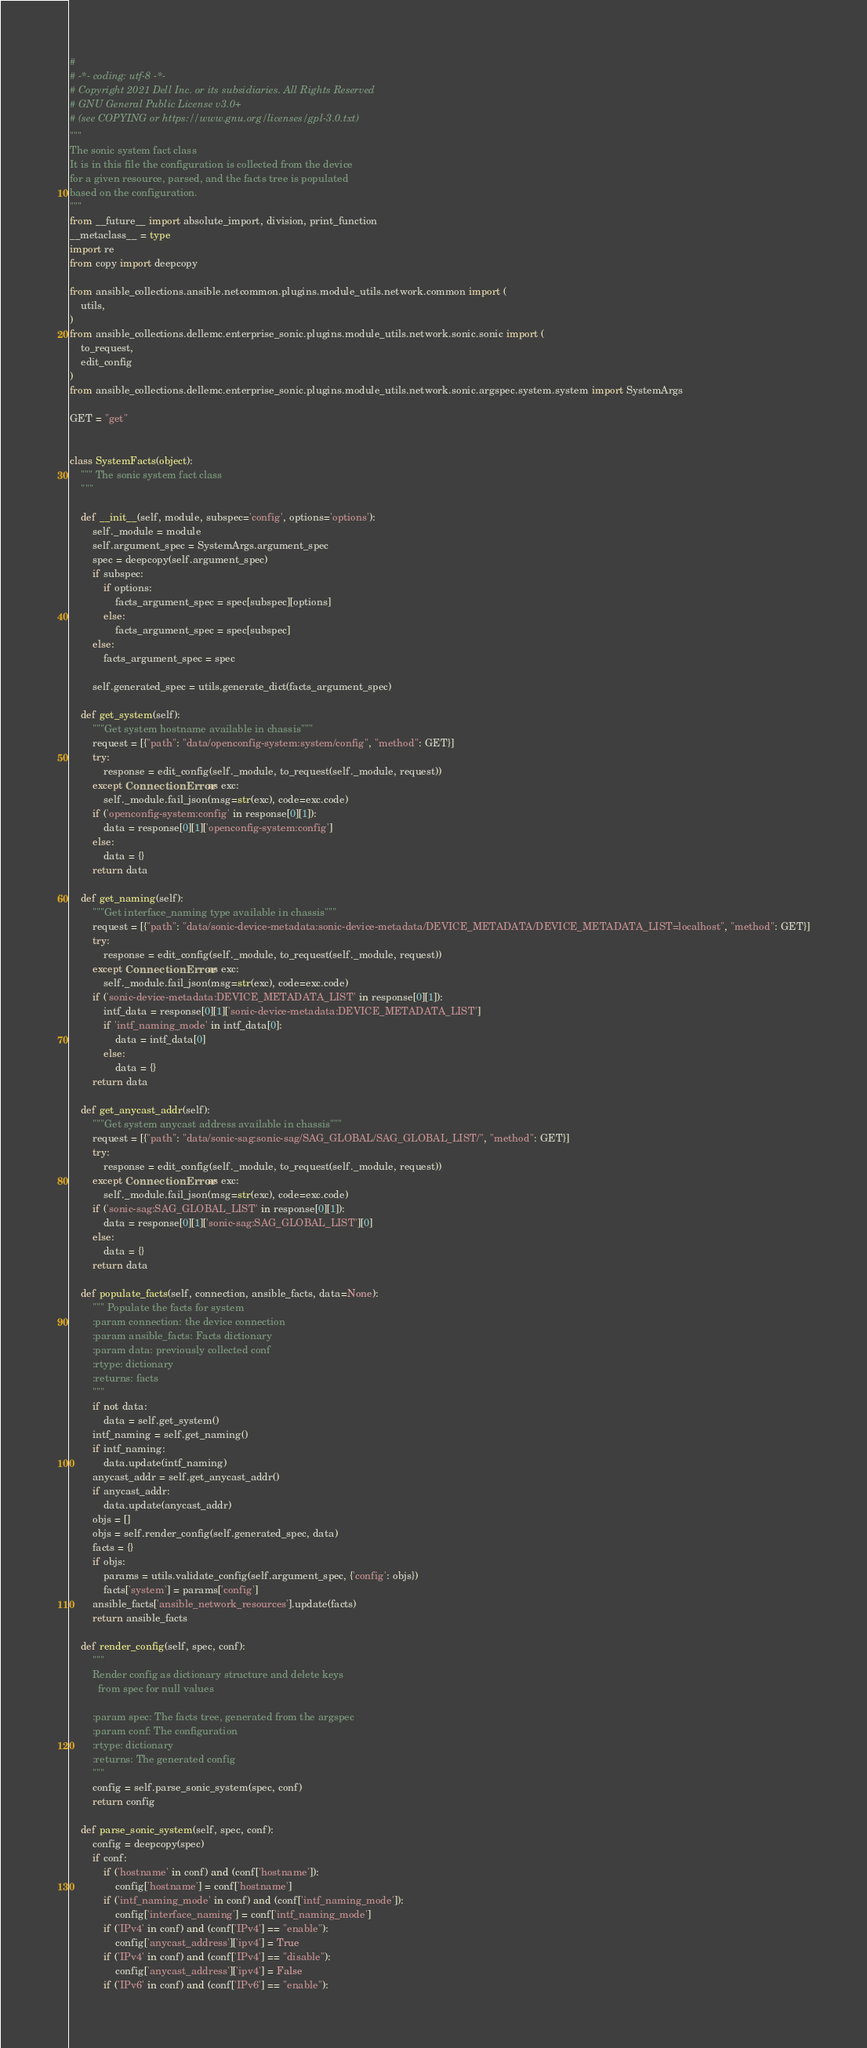Convert code to text. <code><loc_0><loc_0><loc_500><loc_500><_Python_>#
# -*- coding: utf-8 -*-
# Copyright 2021 Dell Inc. or its subsidiaries. All Rights Reserved
# GNU General Public License v3.0+
# (see COPYING or https://www.gnu.org/licenses/gpl-3.0.txt)
"""
The sonic system fact class
It is in this file the configuration is collected from the device
for a given resource, parsed, and the facts tree is populated
based on the configuration.
"""
from __future__ import absolute_import, division, print_function
__metaclass__ = type
import re
from copy import deepcopy

from ansible_collections.ansible.netcommon.plugins.module_utils.network.common import (
    utils,
)
from ansible_collections.dellemc.enterprise_sonic.plugins.module_utils.network.sonic.sonic import (
    to_request,
    edit_config
)
from ansible_collections.dellemc.enterprise_sonic.plugins.module_utils.network.sonic.argspec.system.system import SystemArgs

GET = "get"


class SystemFacts(object):
    """ The sonic system fact class
    """

    def __init__(self, module, subspec='config', options='options'):
        self._module = module
        self.argument_spec = SystemArgs.argument_spec
        spec = deepcopy(self.argument_spec)
        if subspec:
            if options:
                facts_argument_spec = spec[subspec][options]
            else:
                facts_argument_spec = spec[subspec]
        else:
            facts_argument_spec = spec

        self.generated_spec = utils.generate_dict(facts_argument_spec)

    def get_system(self):
        """Get system hostname available in chassis"""
        request = [{"path": "data/openconfig-system:system/config", "method": GET}]
        try:
            response = edit_config(self._module, to_request(self._module, request))
        except ConnectionError as exc:
            self._module.fail_json(msg=str(exc), code=exc.code)
        if ('openconfig-system:config' in response[0][1]):
            data = response[0][1]['openconfig-system:config']
        else:
            data = {}
        return data

    def get_naming(self):
        """Get interface_naming type available in chassis"""
        request = [{"path": "data/sonic-device-metadata:sonic-device-metadata/DEVICE_METADATA/DEVICE_METADATA_LIST=localhost", "method": GET}]
        try:
            response = edit_config(self._module, to_request(self._module, request))
        except ConnectionError as exc:
            self._module.fail_json(msg=str(exc), code=exc.code)
        if ('sonic-device-metadata:DEVICE_METADATA_LIST' in response[0][1]):
            intf_data = response[0][1]['sonic-device-metadata:DEVICE_METADATA_LIST']
            if 'intf_naming_mode' in intf_data[0]:
                data = intf_data[0]
            else:
                data = {}
        return data

    def get_anycast_addr(self):
        """Get system anycast address available in chassis"""
        request = [{"path": "data/sonic-sag:sonic-sag/SAG_GLOBAL/SAG_GLOBAL_LIST/", "method": GET}]
        try:
            response = edit_config(self._module, to_request(self._module, request))
        except ConnectionError as exc:
            self._module.fail_json(msg=str(exc), code=exc.code)
        if ('sonic-sag:SAG_GLOBAL_LIST' in response[0][1]):
            data = response[0][1]['sonic-sag:SAG_GLOBAL_LIST'][0]
        else:
            data = {}
        return data

    def populate_facts(self, connection, ansible_facts, data=None):
        """ Populate the facts for system
        :param connection: the device connection
        :param ansible_facts: Facts dictionary
        :param data: previously collected conf
        :rtype: dictionary
        :returns: facts
        """
        if not data:
            data = self.get_system()
        intf_naming = self.get_naming()
        if intf_naming:
            data.update(intf_naming)
        anycast_addr = self.get_anycast_addr()
        if anycast_addr:
            data.update(anycast_addr)
        objs = []
        objs = self.render_config(self.generated_spec, data)
        facts = {}
        if objs:
            params = utils.validate_config(self.argument_spec, {'config': objs})
            facts['system'] = params['config']
        ansible_facts['ansible_network_resources'].update(facts)
        return ansible_facts

    def render_config(self, spec, conf):
        """
        Render config as dictionary structure and delete keys
          from spec for null values

        :param spec: The facts tree, generated from the argspec
        :param conf: The configuration
        :rtype: dictionary
        :returns: The generated config
        """
        config = self.parse_sonic_system(spec, conf)
        return config

    def parse_sonic_system(self, spec, conf):
        config = deepcopy(spec)
        if conf:
            if ('hostname' in conf) and (conf['hostname']):
                config['hostname'] = conf['hostname']
            if ('intf_naming_mode' in conf) and (conf['intf_naming_mode']):
                config['interface_naming'] = conf['intf_naming_mode']
            if ('IPv4' in conf) and (conf['IPv4'] == "enable"):
                config['anycast_address']['ipv4'] = True
            if ('IPv4' in conf) and (conf['IPv4'] == "disable"):
                config['anycast_address']['ipv4'] = False
            if ('IPv6' in conf) and (conf['IPv6'] == "enable"):</code> 